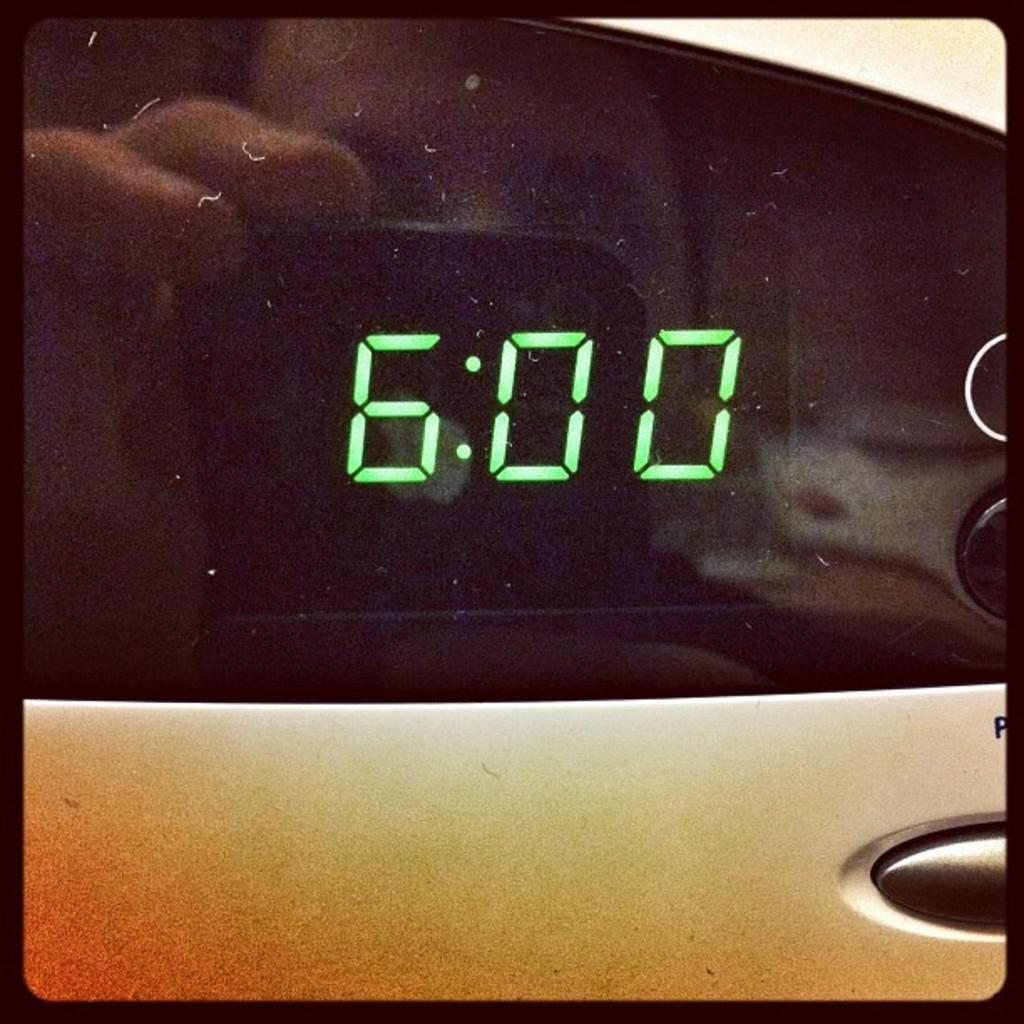<image>
Provide a brief description of the given image. LED screen shows the time 6:00 and the reflection shows a person taking a picture of it. 